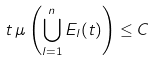Convert formula to latex. <formula><loc_0><loc_0><loc_500><loc_500>t \, \mu \left ( \bigcup _ { l = 1 } ^ { n } E _ { l } ( t ) \right ) \leq C</formula> 